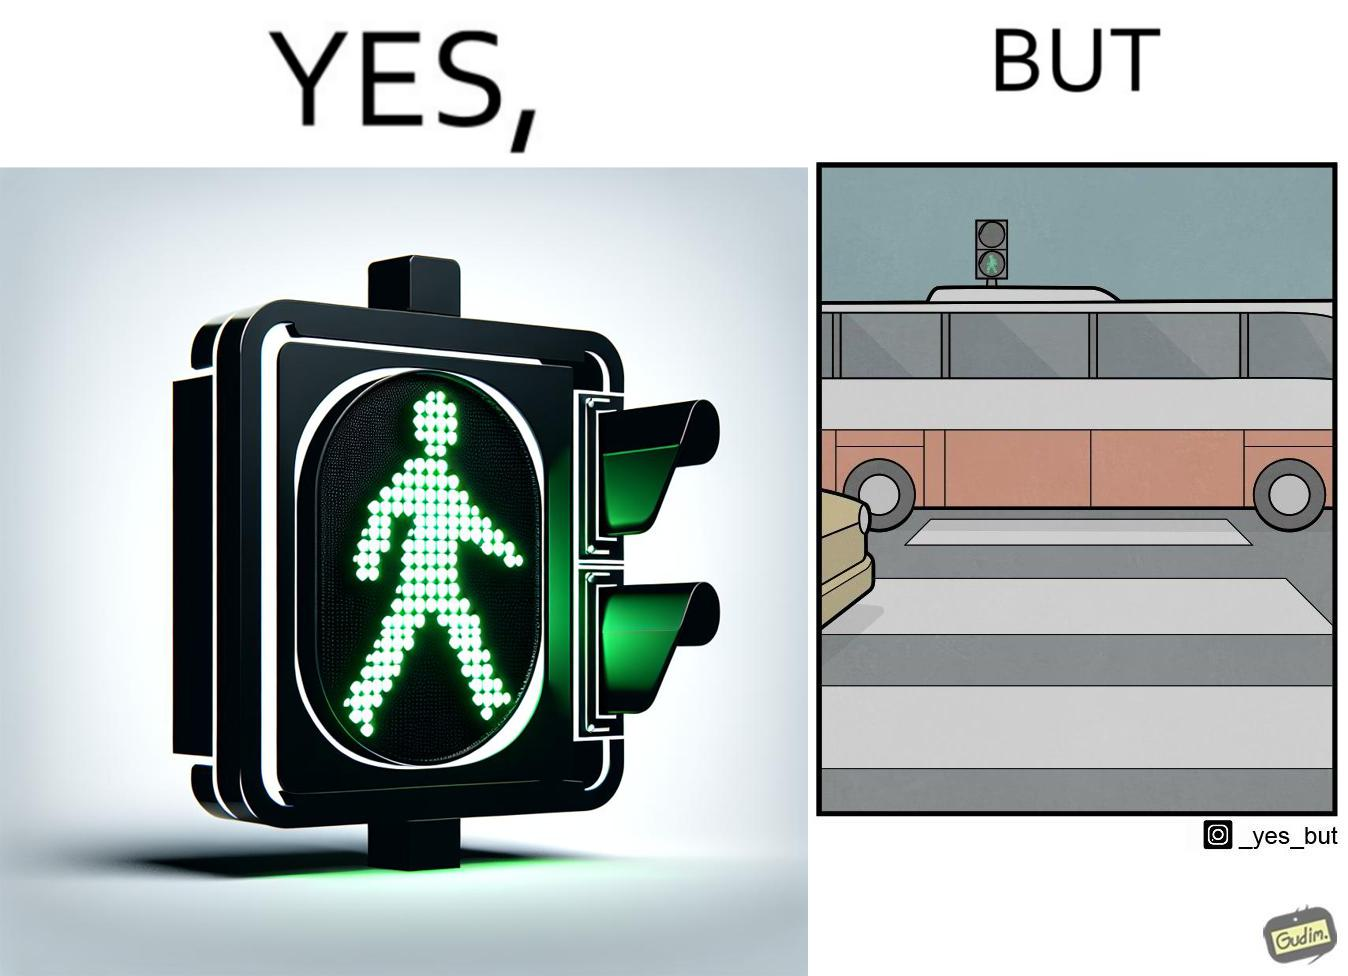What is shown in this image? The image is ironic, because even when the signal is green for the pedestrians but they can't cross the road because of the vehicles standing on the zebra crossing 